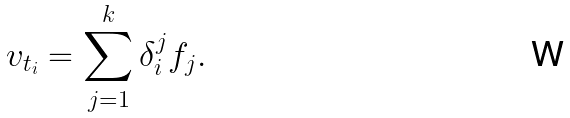<formula> <loc_0><loc_0><loc_500><loc_500>v _ { t _ { i } } = \sum _ { j = 1 } ^ { k } \delta _ { i } ^ { j } f _ { j } .</formula> 